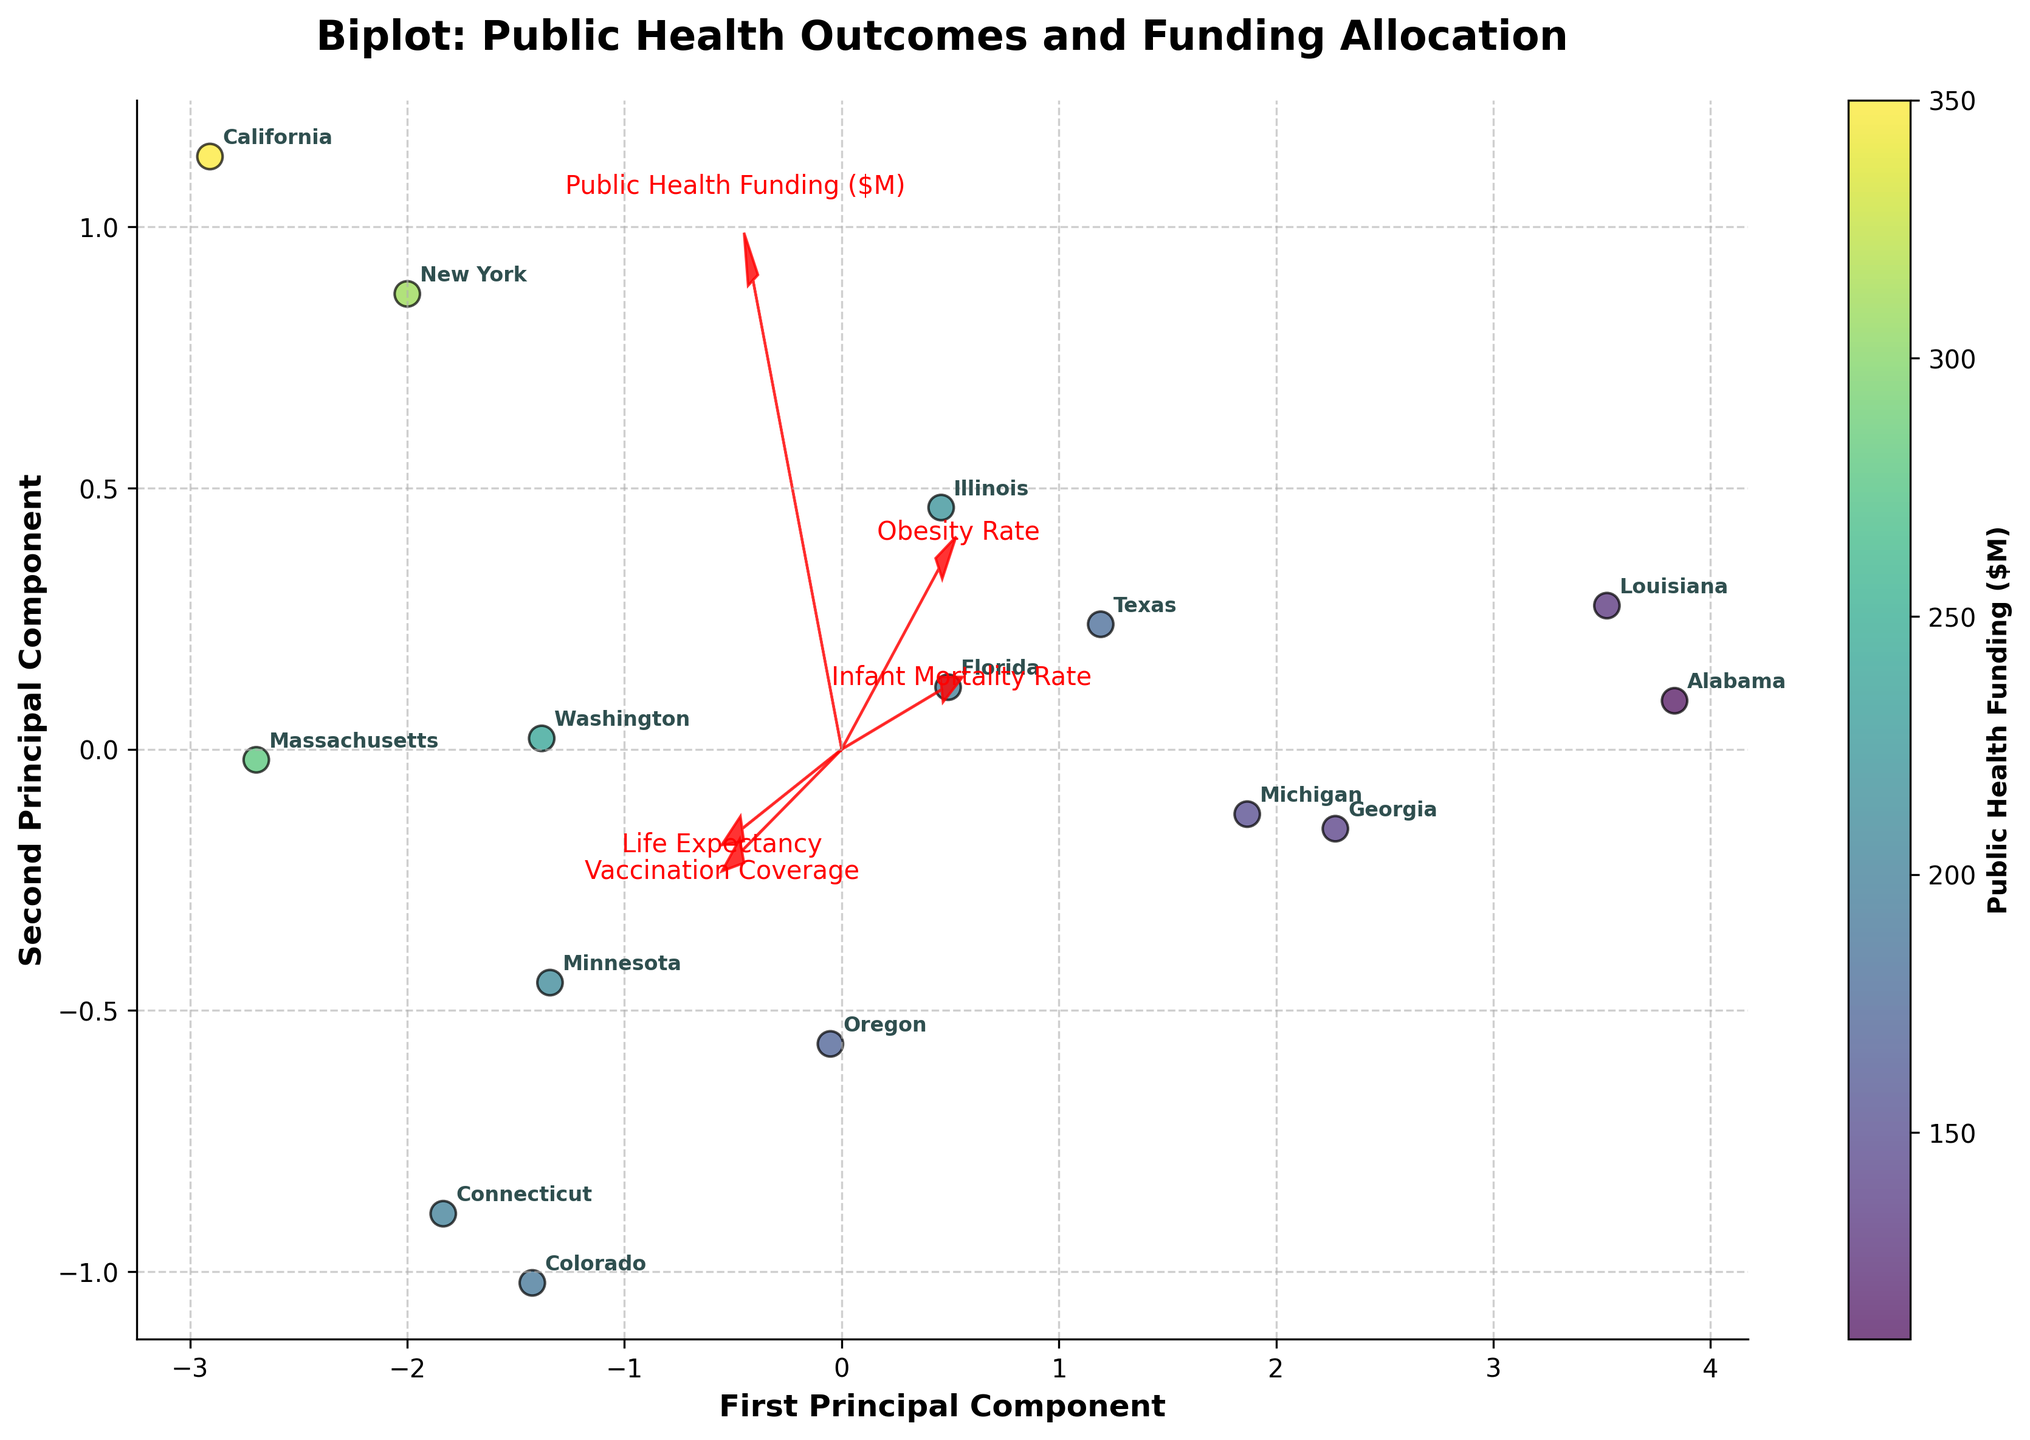What is the title of the figure? The title is typically located at the top of the figure. It provides an overview of what the plot represents. In this case, the title is "Biplot: Public Health Outcomes and Funding Allocation," which is clearly visible at the top of the plot.
Answer: Biplot: Public Health Outcomes and Funding Allocation How many states are represented in the figure? Each state is represented by a label on the plot. Counting the number of state labels will give the total number of states. There are 15 states labeled in the plot.
Answer: 15 Which state has the highest public health funding, based on the color intensity? The color intensity of the data points represents public health funding, with more intense colors indicating higher funding. California shows the highest intensity color, suggesting it has the highest public health funding.
Answer: California What do the arrows represent in the biplot? The arrows in a biplot represent the original variables projected onto the principal component axes. Each arrow points in the direction of maximum variance of each variable, indicating how each public health outcome or funding variable aligns with the principal components.
Answer: Original variables Which feature appears to have the strongest influence on the first principal component? By observing the direction and length of the arrows, the feature with the arrow pointing furthest along the direction of the first principal component (horizontal axis) indicates the strongest influence. The Public Health Funding variable's arrow extends furthest along the first component.
Answer: Public Health Funding Are there any states with similar positions on the biplot? By visually inspecting the plot, states that are close to each other have similar scores on the principal components. New York and Connecticut are closely positioned, indicating that they have similar public health outcomes and funding profiles.
Answer: New York and Connecticut Which feature has an arrow pointing in the opposite direction to the Infant Mortality Rate? On the biplot, features with arrows pointing in opposite directions are negatively correlated. The Life Expectancy arrow points in the opposite direction to the Infant Mortality Rate arrow.
Answer: Life Expectancy Which state has the lowest life expectancy and how can you tell? To determine this, look for the state with the data point positioned furthest in the direction of the negative end of the Life Expectancy arrow. Alabama's position indicates it has the lowest life expectancy.
Answer: Alabama How can we interpret the relationship between obesity rate and public health funding? By examining the arrows associated with obesity rate and public health funding, if the arrows are pointing in similar directions, it indicates a positive correlation. The arrows for obesity rate and public health funding do not point in the same direction, indicating that these variables are not strongly positively correlated.
Answer: Not strongly positively correlated Which axes represent the first and second principal components? The first principal component is typically represented on the horizontal axis, while the second principal component is represented on the vertical axis. The plot's axis labels indicate this configuration.
Answer: Horizontal and vertical 